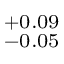<formula> <loc_0><loc_0><loc_500><loc_500>^ { + 0 . 0 9 } _ { - 0 . 0 5 }</formula> 